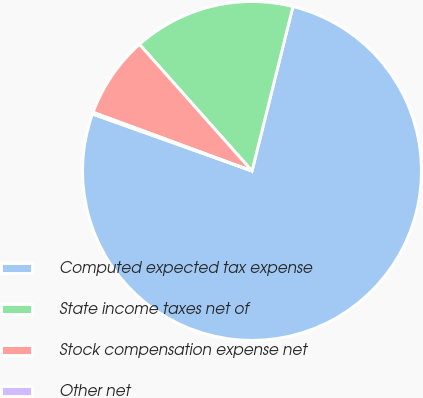Convert chart. <chart><loc_0><loc_0><loc_500><loc_500><pie_chart><fcel>Computed expected tax expense<fcel>State income taxes net of<fcel>Stock compensation expense net<fcel>Other net<nl><fcel>76.57%<fcel>15.45%<fcel>7.81%<fcel>0.17%<nl></chart> 